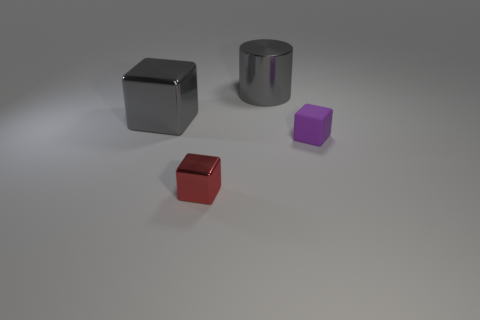There is a big cube that is the same color as the cylinder; what is its material?
Ensure brevity in your answer.  Metal. How many metal things are things or tiny red objects?
Offer a very short reply. 3. The purple rubber block has what size?
Give a very brief answer. Small. How many things are metallic balls or things that are on the right side of the red metal cube?
Offer a terse response. 2. How many other things are the same color as the tiny metallic cube?
Your response must be concise. 0. There is a gray block; does it have the same size as the gray metal thing that is behind the large gray metal block?
Offer a very short reply. Yes. There is a metallic block behind the rubber cube; is its size the same as the tiny purple rubber cube?
Provide a succinct answer. No. What number of other objects are there of the same material as the purple cube?
Ensure brevity in your answer.  0. Are there an equal number of large gray things that are on the left side of the gray cylinder and purple blocks on the left side of the tiny red cube?
Offer a very short reply. No. The object in front of the small thing that is behind the tiny object on the left side of the matte object is what color?
Give a very brief answer. Red. 